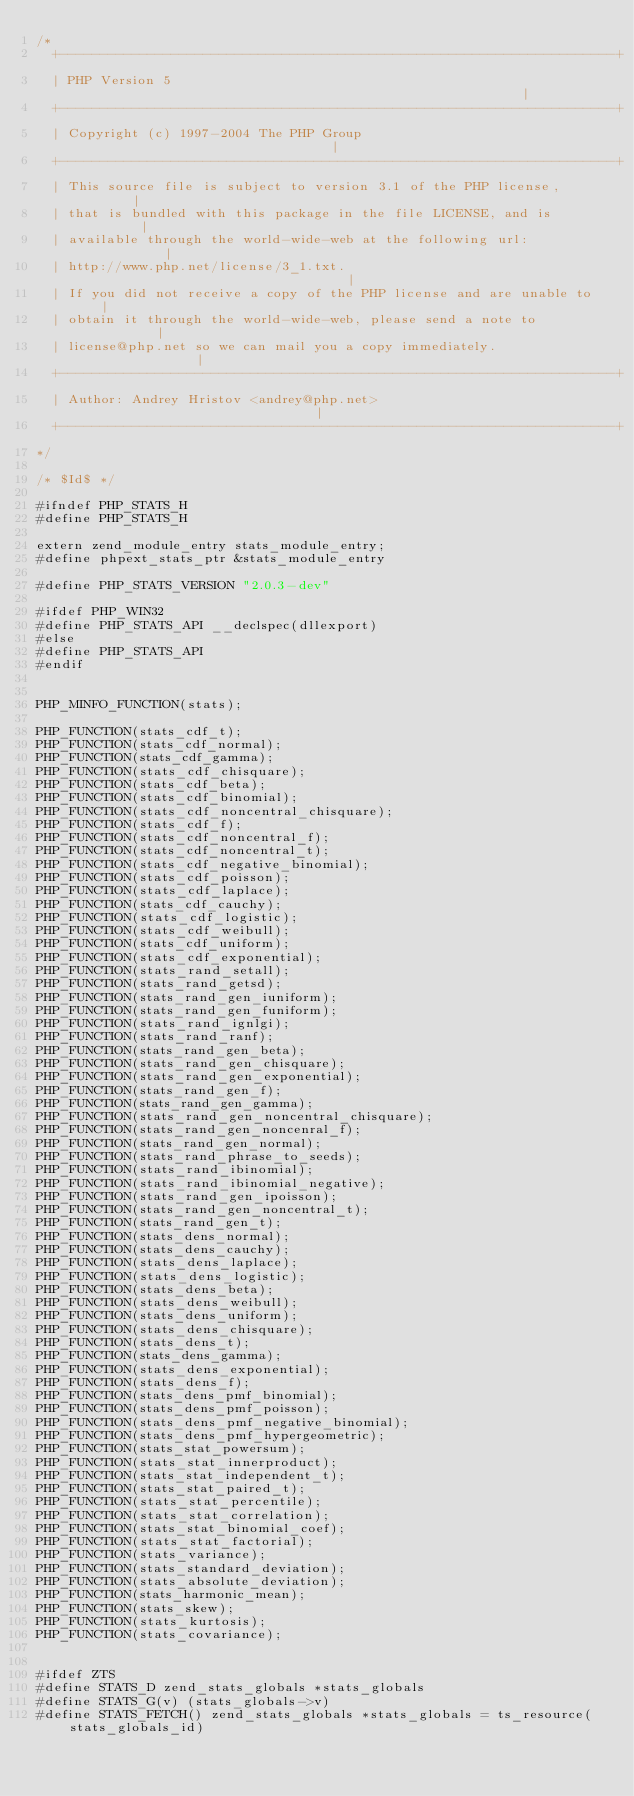<code> <loc_0><loc_0><loc_500><loc_500><_C_>/*
  +----------------------------------------------------------------------+
  | PHP Version 5                                                        |
  +----------------------------------------------------------------------+
  | Copyright (c) 1997-2004 The PHP Group                                |
  +----------------------------------------------------------------------+
  | This source file is subject to version 3.1 of the PHP license,       |
  | that is bundled with this package in the file LICENSE, and is        |
  | available through the world-wide-web at the following url:           |
  | http://www.php.net/license/3_1.txt.                                  |
  | If you did not receive a copy of the PHP license and are unable to   |
  | obtain it through the world-wide-web, please send a note to          |
  | license@php.net so we can mail you a copy immediately.               |
  +----------------------------------------------------------------------+
  | Author: Andrey Hristov <andrey@php.net>                              |
  +----------------------------------------------------------------------+
*/

/* $Id$ */

#ifndef PHP_STATS_H
#define PHP_STATS_H

extern zend_module_entry stats_module_entry;
#define phpext_stats_ptr &stats_module_entry

#define PHP_STATS_VERSION "2.0.3-dev"

#ifdef PHP_WIN32
#define PHP_STATS_API __declspec(dllexport)
#else
#define PHP_STATS_API
#endif


PHP_MINFO_FUNCTION(stats);

PHP_FUNCTION(stats_cdf_t);
PHP_FUNCTION(stats_cdf_normal);
PHP_FUNCTION(stats_cdf_gamma);
PHP_FUNCTION(stats_cdf_chisquare);
PHP_FUNCTION(stats_cdf_beta);
PHP_FUNCTION(stats_cdf_binomial);
PHP_FUNCTION(stats_cdf_noncentral_chisquare);
PHP_FUNCTION(stats_cdf_f);
PHP_FUNCTION(stats_cdf_noncentral_f);
PHP_FUNCTION(stats_cdf_noncentral_t);
PHP_FUNCTION(stats_cdf_negative_binomial);
PHP_FUNCTION(stats_cdf_poisson);
PHP_FUNCTION(stats_cdf_laplace);
PHP_FUNCTION(stats_cdf_cauchy);
PHP_FUNCTION(stats_cdf_logistic);
PHP_FUNCTION(stats_cdf_weibull);
PHP_FUNCTION(stats_cdf_uniform);
PHP_FUNCTION(stats_cdf_exponential);
PHP_FUNCTION(stats_rand_setall);
PHP_FUNCTION(stats_rand_getsd);
PHP_FUNCTION(stats_rand_gen_iuniform);
PHP_FUNCTION(stats_rand_gen_funiform);
PHP_FUNCTION(stats_rand_ignlgi);
PHP_FUNCTION(stats_rand_ranf);
PHP_FUNCTION(stats_rand_gen_beta);
PHP_FUNCTION(stats_rand_gen_chisquare);
PHP_FUNCTION(stats_rand_gen_exponential);
PHP_FUNCTION(stats_rand_gen_f);
PHP_FUNCTION(stats_rand_gen_gamma);
PHP_FUNCTION(stats_rand_gen_noncentral_chisquare);
PHP_FUNCTION(stats_rand_gen_noncenral_f);
PHP_FUNCTION(stats_rand_gen_normal);
PHP_FUNCTION(stats_rand_phrase_to_seeds);
PHP_FUNCTION(stats_rand_ibinomial);
PHP_FUNCTION(stats_rand_ibinomial_negative);
PHP_FUNCTION(stats_rand_gen_ipoisson);
PHP_FUNCTION(stats_rand_gen_noncentral_t);
PHP_FUNCTION(stats_rand_gen_t);
PHP_FUNCTION(stats_dens_normal);
PHP_FUNCTION(stats_dens_cauchy);
PHP_FUNCTION(stats_dens_laplace);
PHP_FUNCTION(stats_dens_logistic);
PHP_FUNCTION(stats_dens_beta);
PHP_FUNCTION(stats_dens_weibull);
PHP_FUNCTION(stats_dens_uniform);
PHP_FUNCTION(stats_dens_chisquare);
PHP_FUNCTION(stats_dens_t);
PHP_FUNCTION(stats_dens_gamma);
PHP_FUNCTION(stats_dens_exponential);
PHP_FUNCTION(stats_dens_f);
PHP_FUNCTION(stats_dens_pmf_binomial);
PHP_FUNCTION(stats_dens_pmf_poisson);
PHP_FUNCTION(stats_dens_pmf_negative_binomial);
PHP_FUNCTION(stats_dens_pmf_hypergeometric);
PHP_FUNCTION(stats_stat_powersum);
PHP_FUNCTION(stats_stat_innerproduct);
PHP_FUNCTION(stats_stat_independent_t);
PHP_FUNCTION(stats_stat_paired_t);
PHP_FUNCTION(stats_stat_percentile);
PHP_FUNCTION(stats_stat_correlation);
PHP_FUNCTION(stats_stat_binomial_coef);
PHP_FUNCTION(stats_stat_factorial);
PHP_FUNCTION(stats_variance);
PHP_FUNCTION(stats_standard_deviation);
PHP_FUNCTION(stats_absolute_deviation);
PHP_FUNCTION(stats_harmonic_mean);
PHP_FUNCTION(stats_skew);
PHP_FUNCTION(stats_kurtosis);
PHP_FUNCTION(stats_covariance);


#ifdef ZTS
#define STATS_D zend_stats_globals *stats_globals
#define STATS_G(v) (stats_globals->v)
#define STATS_FETCH() zend_stats_globals *stats_globals = ts_resource(stats_globals_id)</code> 